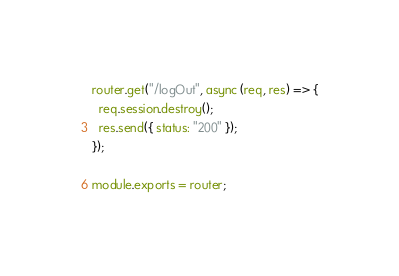<code> <loc_0><loc_0><loc_500><loc_500><_JavaScript_>router.get("/logOut", async (req, res) => {
  req.session.destroy();
  res.send({ status: "200" });
});

module.exports = router;
</code> 